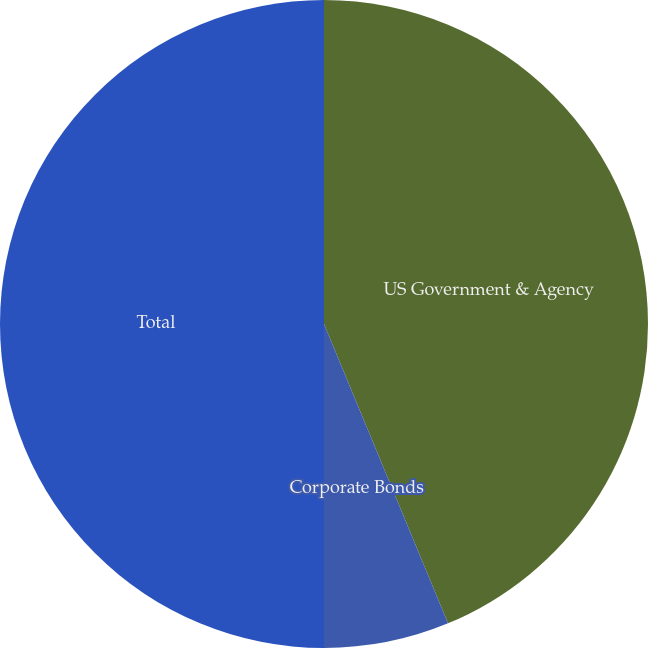Convert chart to OTSL. <chart><loc_0><loc_0><loc_500><loc_500><pie_chart><fcel>US Government & Agency<fcel>Corporate Bonds<fcel>Total<nl><fcel>43.75%<fcel>6.25%<fcel>50.0%<nl></chart> 